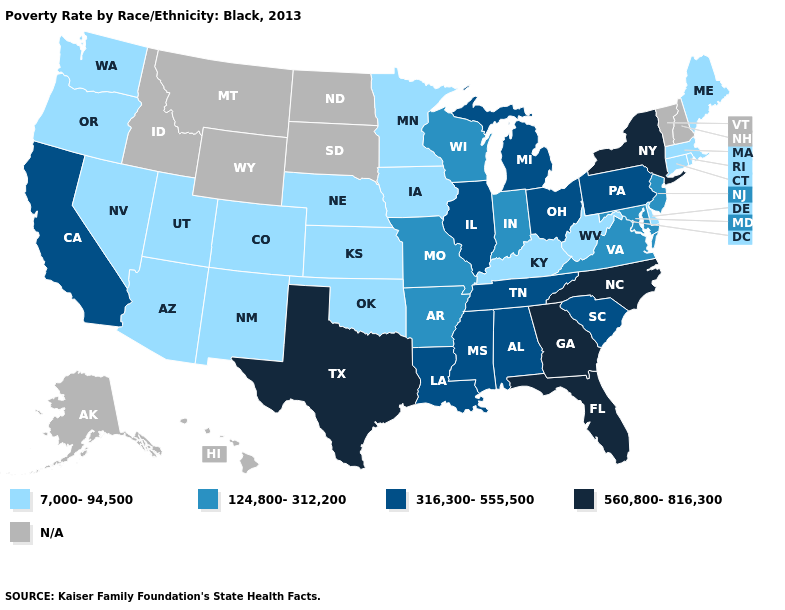Name the states that have a value in the range 124,800-312,200?
Concise answer only. Arkansas, Indiana, Maryland, Missouri, New Jersey, Virginia, Wisconsin. Which states have the highest value in the USA?
Answer briefly. Florida, Georgia, New York, North Carolina, Texas. What is the highest value in the Northeast ?
Give a very brief answer. 560,800-816,300. Name the states that have a value in the range 124,800-312,200?
Write a very short answer. Arkansas, Indiana, Maryland, Missouri, New Jersey, Virginia, Wisconsin. Name the states that have a value in the range N/A?
Concise answer only. Alaska, Hawaii, Idaho, Montana, New Hampshire, North Dakota, South Dakota, Vermont, Wyoming. Does the first symbol in the legend represent the smallest category?
Give a very brief answer. Yes. Which states have the lowest value in the Northeast?
Be succinct. Connecticut, Maine, Massachusetts, Rhode Island. What is the value of Colorado?
Be succinct. 7,000-94,500. Which states have the lowest value in the USA?
Answer briefly. Arizona, Colorado, Connecticut, Delaware, Iowa, Kansas, Kentucky, Maine, Massachusetts, Minnesota, Nebraska, Nevada, New Mexico, Oklahoma, Oregon, Rhode Island, Utah, Washington, West Virginia. How many symbols are there in the legend?
Be succinct. 5. Name the states that have a value in the range 560,800-816,300?
Write a very short answer. Florida, Georgia, New York, North Carolina, Texas. What is the value of California?
Answer briefly. 316,300-555,500. Name the states that have a value in the range 7,000-94,500?
Short answer required. Arizona, Colorado, Connecticut, Delaware, Iowa, Kansas, Kentucky, Maine, Massachusetts, Minnesota, Nebraska, Nevada, New Mexico, Oklahoma, Oregon, Rhode Island, Utah, Washington, West Virginia. 